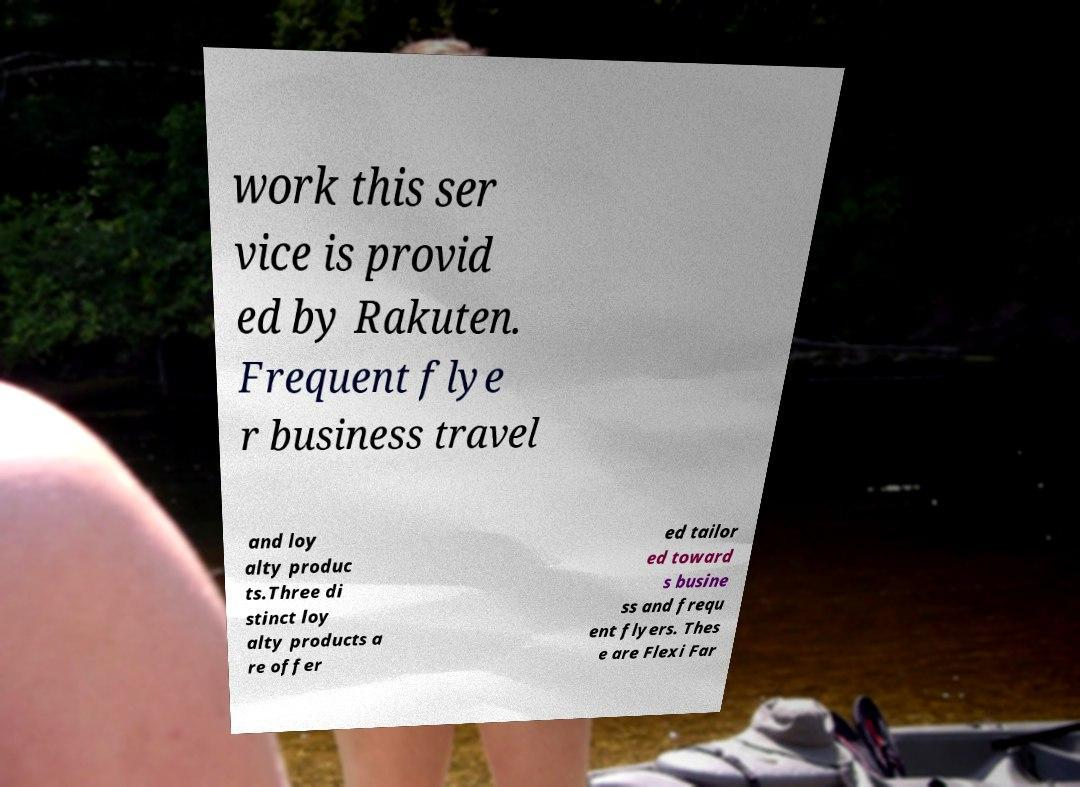I need the written content from this picture converted into text. Can you do that? work this ser vice is provid ed by Rakuten. Frequent flye r business travel and loy alty produc ts.Three di stinct loy alty products a re offer ed tailor ed toward s busine ss and frequ ent flyers. Thes e are Flexi Far 